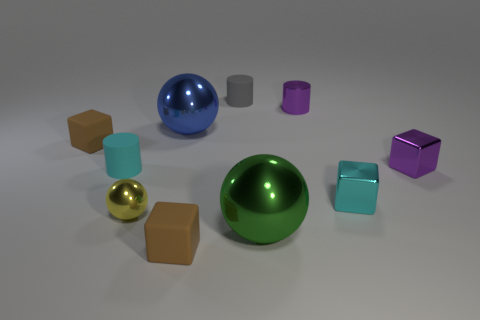Subtract all balls. How many objects are left? 7 Subtract all small brown spheres. Subtract all small purple cubes. How many objects are left? 9 Add 5 tiny cyan matte cylinders. How many tiny cyan matte cylinders are left? 6 Add 2 small cyan things. How many small cyan things exist? 4 Subtract 0 red cubes. How many objects are left? 10 